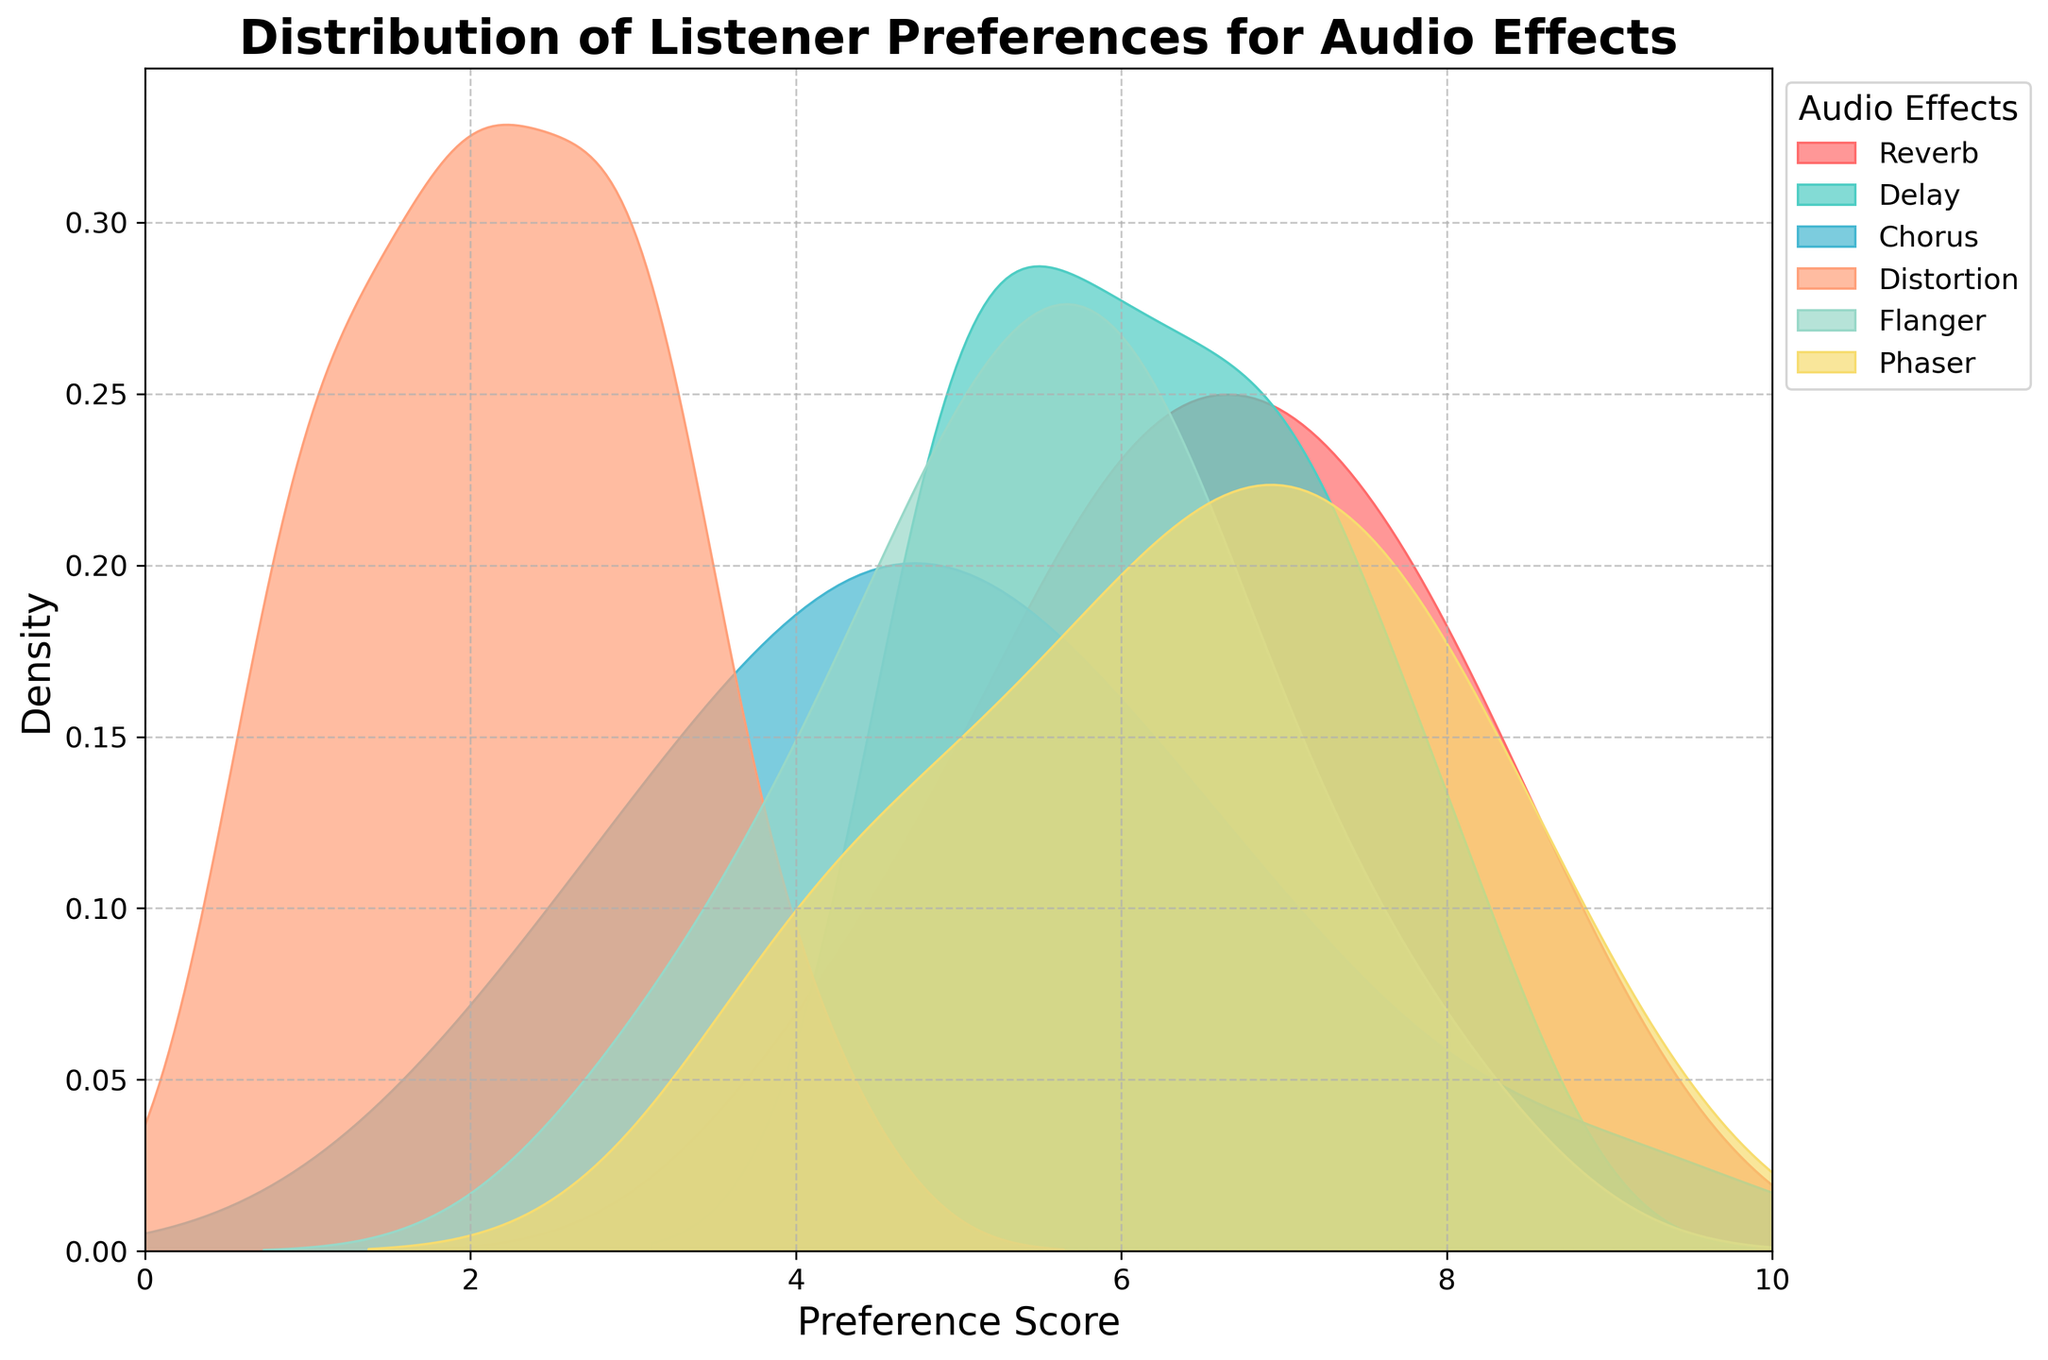What is the title of the figure? The title is written at the top of the figure and provides an overview of what the figure represents. By reading the top section, we can see the title.
Answer: Distribution of Listener Preferences for Audio Effects What does the x-axis represent? The x-axis is the horizontal axis of the figure, typically representing the variable being measured. In this case, the x-axis has labels ranging from 0 to 10, indicating these are preference scores.
Answer: Preference Score Which audio effect has the highest average preference score? By observing the density curves, the area under the curve gives an indication of the average level of preference for each effect. The effect with the peak position further right typically has the highest average score.
Answer: Reverb What can you say about the variability in preferences for the Flanger effect compared to the Phaser effect? The width of the density curves represents the variability of preferences. A wider curve indicates higher variability, whereas a narrower curve indicates lower variability.
Answer: Flanger has higher variability than Phaser Which audio effect shows the least preference among listeners? To identify the least preferred effect, look at the density of the curves on the lower end of the preference score. The curve with the highest density at the lower end shows the least preference.
Answer: Distortion Do any audio effects have similar distributions in listener preferences? By comparing the shapes and positions of the density curves for each effect, we can identify if any two effects have overlapping distributions or similar shapes.
Answer: Delay and Phaser Which audio effects show a bimodal distribution? A bimodal distribution has two peaks. By inspecting the curves, we can identify which effect has a curve with two distinct peaks.
Answer: None How does the preference for Distortion compare to Reverb? By looking at both the peak of the density curve and the position on the x-axis, we can compare the preference scores for Distortion and Reverb. The peaks and spread provide information on how these effects are rated comparatively.
Answer: Reverb is more preferred than Distortion 